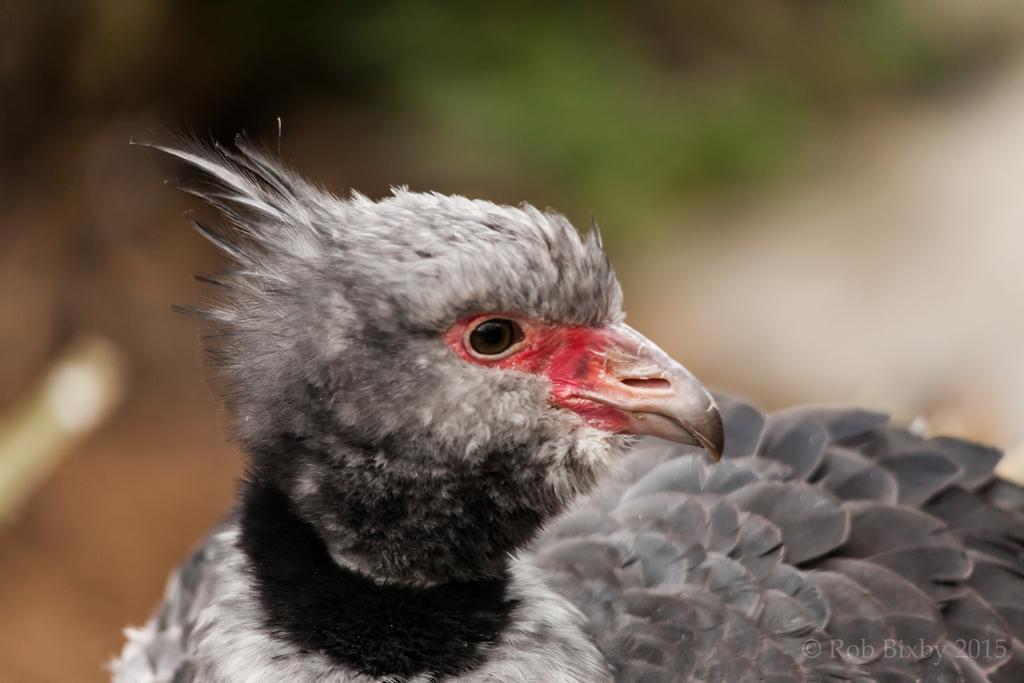Describe this image in one or two sentences. In the image we can see a bird. Background of the image is blur. 